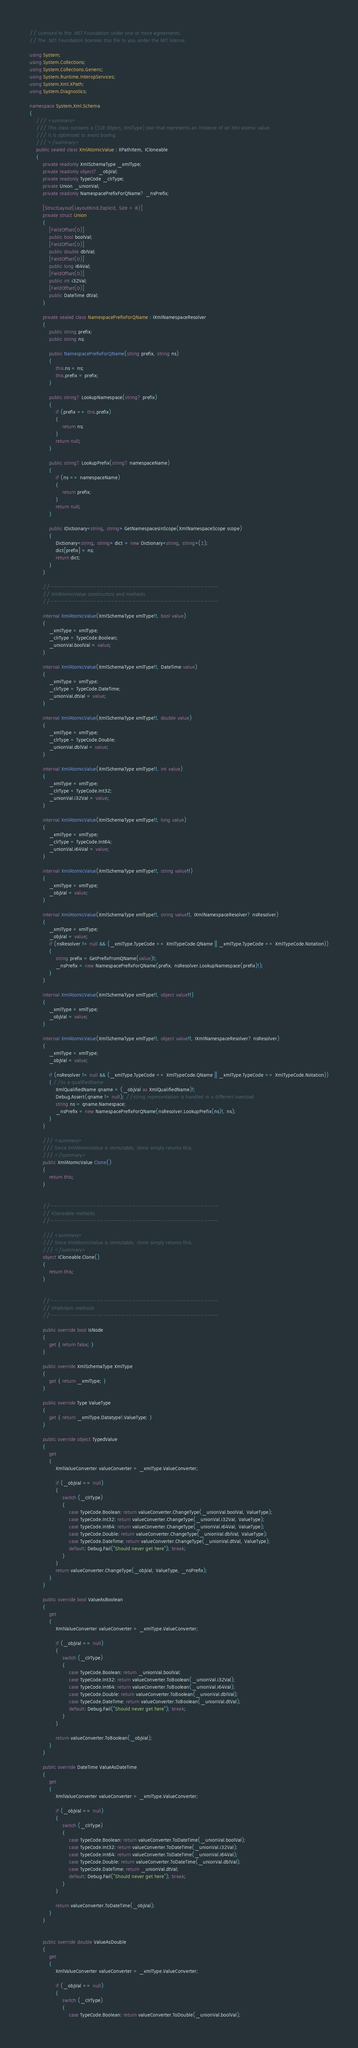<code> <loc_0><loc_0><loc_500><loc_500><_C#_>// Licensed to the .NET Foundation under one or more agreements.
// The .NET Foundation licenses this file to you under the MIT license.

using System;
using System.Collections;
using System.Collections.Generic;
using System.Runtime.InteropServices;
using System.Xml.XPath;
using System.Diagnostics;

namespace System.Xml.Schema
{
    /// <summary>
    /// This class contains a (CLR Object, XmlType) pair that represents an instance of an Xml atomic value.
    /// It is optimized to avoid boxing.
    /// </summary>
    public sealed class XmlAtomicValue : XPathItem, ICloneable
    {
        private readonly XmlSchemaType _xmlType;
        private readonly object? _objVal;
        private readonly TypeCode _clrType;
        private Union _unionVal;
        private readonly NamespacePrefixForQName? _nsPrefix;

        [StructLayout(LayoutKind.Explicit, Size = 8)]
        private struct Union
        {
            [FieldOffset(0)]
            public bool boolVal;
            [FieldOffset(0)]
            public double dblVal;
            [FieldOffset(0)]
            public long i64Val;
            [FieldOffset(0)]
            public int i32Val;
            [FieldOffset(0)]
            public DateTime dtVal;
        }

        private sealed class NamespacePrefixForQName : IXmlNamespaceResolver
        {
            public string prefix;
            public string ns;

            public NamespacePrefixForQName(string prefix, string ns)
            {
                this.ns = ns;
                this.prefix = prefix;
            }

            public string? LookupNamespace(string? prefix)
            {
                if (prefix == this.prefix)
                {
                    return ns;
                }
                return null;
            }

            public string? LookupPrefix(string? namespaceName)
            {
                if (ns == namespaceName)
                {
                    return prefix;
                }
                return null;
            }

            public IDictionary<string, string> GetNamespacesInScope(XmlNamespaceScope scope)
            {
                Dictionary<string, string> dict = new Dictionary<string, string>(1);
                dict[prefix] = ns;
                return dict;
            }
        }

        //-----------------------------------------------
        // XmlAtomicValue constructors and methods
        //-----------------------------------------------

        internal XmlAtomicValue(XmlSchemaType xmlType!!, bool value)
        {
            _xmlType = xmlType;
            _clrType = TypeCode.Boolean;
            _unionVal.boolVal = value;
        }

        internal XmlAtomicValue(XmlSchemaType xmlType!!, DateTime value)
        {
            _xmlType = xmlType;
            _clrType = TypeCode.DateTime;
            _unionVal.dtVal = value;
        }

        internal XmlAtomicValue(XmlSchemaType xmlType!!, double value)
        {
            _xmlType = xmlType;
            _clrType = TypeCode.Double;
            _unionVal.dblVal = value;
        }

        internal XmlAtomicValue(XmlSchemaType xmlType!!, int value)
        {
            _xmlType = xmlType;
            _clrType = TypeCode.Int32;
            _unionVal.i32Val = value;
        }

        internal XmlAtomicValue(XmlSchemaType xmlType!!, long value)
        {
            _xmlType = xmlType;
            _clrType = TypeCode.Int64;
            _unionVal.i64Val = value;
        }

        internal XmlAtomicValue(XmlSchemaType xmlType!!, string value!!)
        {
            _xmlType = xmlType;
            _objVal = value;
        }

        internal XmlAtomicValue(XmlSchemaType xmlType!!, string value!!, IXmlNamespaceResolver? nsResolver)
        {
            _xmlType = xmlType;
            _objVal = value;
            if (nsResolver != null && (_xmlType.TypeCode == XmlTypeCode.QName || _xmlType.TypeCode == XmlTypeCode.Notation))
            {
                string prefix = GetPrefixFromQName(value)!;
                _nsPrefix = new NamespacePrefixForQName(prefix, nsResolver.LookupNamespace(prefix)!);
            }
        }

        internal XmlAtomicValue(XmlSchemaType xmlType!!, object value!!)
        {
            _xmlType = xmlType;
            _objVal = value;
        }

        internal XmlAtomicValue(XmlSchemaType xmlType!!, object value!!, IXmlNamespaceResolver? nsResolver)
        {
            _xmlType = xmlType;
            _objVal = value;

            if (nsResolver != null && (_xmlType.TypeCode == XmlTypeCode.QName || _xmlType.TypeCode == XmlTypeCode.Notation))
            { //Its a qualifiedName
                XmlQualifiedName qname = (_objVal as XmlQualifiedName)!;
                Debug.Assert(qname != null); //string representation is handled in a different overload
                string ns = qname.Namespace;
                _nsPrefix = new NamespacePrefixForQName(nsResolver.LookupPrefix(ns)!, ns);
            }
        }

        /// <summary>
        /// Since XmlAtomicValue is immutable, clone simply returns this.
        /// </summary>
        public XmlAtomicValue Clone()
        {
            return this;
        }


        //-----------------------------------------------
        // ICloneable methods
        //-----------------------------------------------

        /// <summary>
        /// Since XmlAtomicValue is immutable, clone simply returns this.
        /// </summary>
        object ICloneable.Clone()
        {
            return this;
        }


        //-----------------------------------------------
        // XPathItem methods
        //-----------------------------------------------

        public override bool IsNode
        {
            get { return false; }
        }

        public override XmlSchemaType XmlType
        {
            get { return _xmlType; }
        }

        public override Type ValueType
        {
            get { return _xmlType.Datatype!.ValueType; }
        }

        public override object TypedValue
        {
            get
            {
                XmlValueConverter valueConverter = _xmlType.ValueConverter;

                if (_objVal == null)
                {
                    switch (_clrType)
                    {
                        case TypeCode.Boolean: return valueConverter.ChangeType(_unionVal.boolVal, ValueType);
                        case TypeCode.Int32: return valueConverter.ChangeType(_unionVal.i32Val, ValueType);
                        case TypeCode.Int64: return valueConverter.ChangeType(_unionVal.i64Val, ValueType);
                        case TypeCode.Double: return valueConverter.ChangeType(_unionVal.dblVal, ValueType);
                        case TypeCode.DateTime: return valueConverter.ChangeType(_unionVal.dtVal, ValueType);
                        default: Debug.Fail("Should never get here"); break;
                    }
                }
                return valueConverter.ChangeType(_objVal, ValueType, _nsPrefix);
            }
        }

        public override bool ValueAsBoolean
        {
            get
            {
                XmlValueConverter valueConverter = _xmlType.ValueConverter;

                if (_objVal == null)
                {
                    switch (_clrType)
                    {
                        case TypeCode.Boolean: return _unionVal.boolVal;
                        case TypeCode.Int32: return valueConverter.ToBoolean(_unionVal.i32Val);
                        case TypeCode.Int64: return valueConverter.ToBoolean(_unionVal.i64Val);
                        case TypeCode.Double: return valueConverter.ToBoolean(_unionVal.dblVal);
                        case TypeCode.DateTime: return valueConverter.ToBoolean(_unionVal.dtVal);
                        default: Debug.Fail("Should never get here"); break;
                    }
                }

                return valueConverter.ToBoolean(_objVal);
            }
        }

        public override DateTime ValueAsDateTime
        {
            get
            {
                XmlValueConverter valueConverter = _xmlType.ValueConverter;

                if (_objVal == null)
                {
                    switch (_clrType)
                    {
                        case TypeCode.Boolean: return valueConverter.ToDateTime(_unionVal.boolVal);
                        case TypeCode.Int32: return valueConverter.ToDateTime(_unionVal.i32Val);
                        case TypeCode.Int64: return valueConverter.ToDateTime(_unionVal.i64Val);
                        case TypeCode.Double: return valueConverter.ToDateTime(_unionVal.dblVal);
                        case TypeCode.DateTime: return _unionVal.dtVal;
                        default: Debug.Fail("Should never get here"); break;
                    }
                }

                return valueConverter.ToDateTime(_objVal);
            }
        }


        public override double ValueAsDouble
        {
            get
            {
                XmlValueConverter valueConverter = _xmlType.ValueConverter;

                if (_objVal == null)
                {
                    switch (_clrType)
                    {
                        case TypeCode.Boolean: return valueConverter.ToDouble(_unionVal.boolVal);</code> 